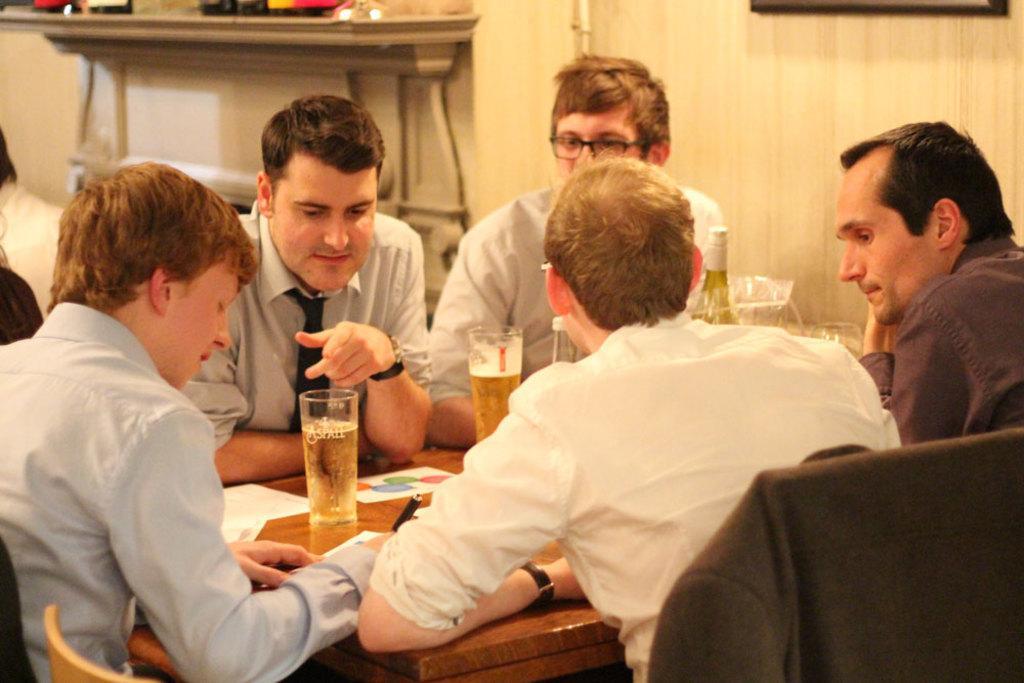Describe this image in one or two sentences. There are five persons sitting on the chairs around the table. There are glasses with drinks, bottles, papers and pens on the table. 